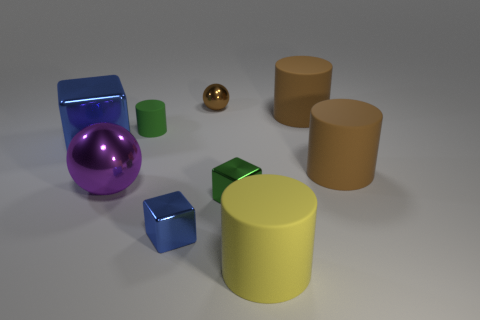Add 1 cylinders. How many objects exist? 10 Subtract all cylinders. How many objects are left? 5 Add 3 small green objects. How many small green objects exist? 5 Subtract 0 blue balls. How many objects are left? 9 Subtract all tiny cylinders. Subtract all green cylinders. How many objects are left? 7 Add 7 blue blocks. How many blue blocks are left? 9 